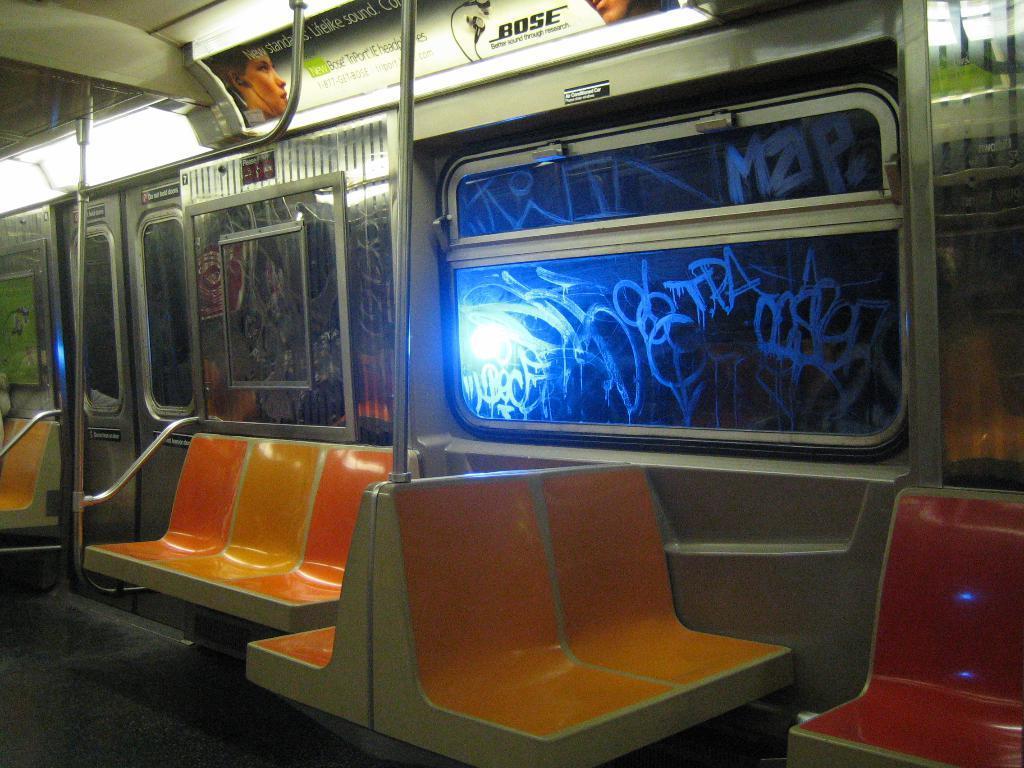Can you describe this image briefly? I think this picture was taken inside the train. These are the seats. This looks like a window with the glass door. I can see the doors. This looks like a poster, which is attached to the train. 